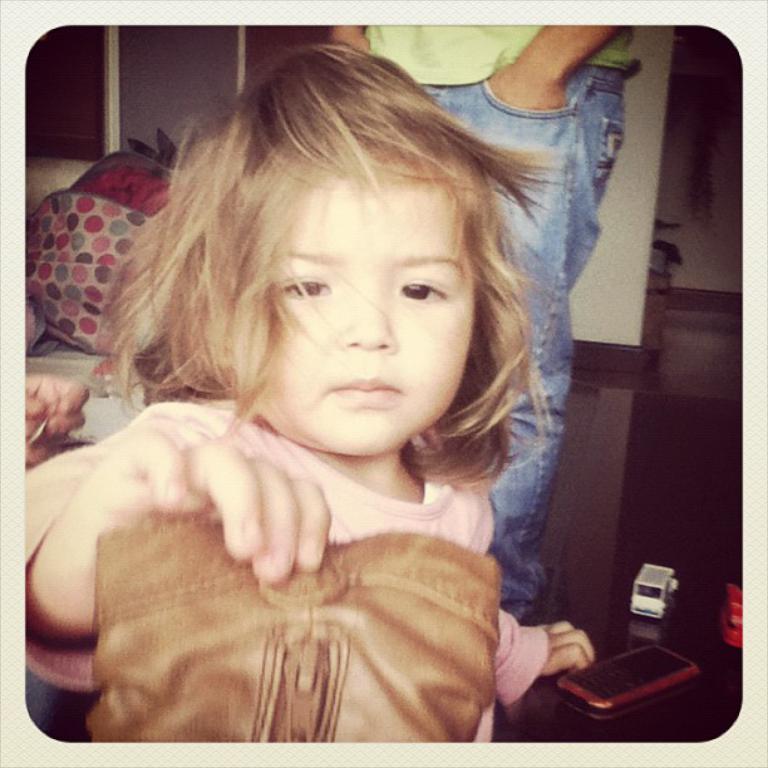Could you give a brief overview of what you see in this image? In this image there is a girl holding a bag in her hand, in the background there is a man standing and there is a wall, beside the girl there is a table, on that table there is a mobile and toys. 